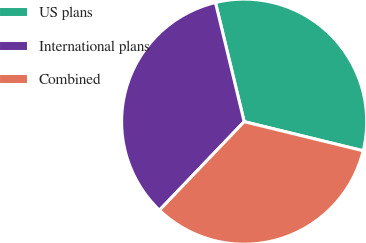Convert chart. <chart><loc_0><loc_0><loc_500><loc_500><pie_chart><fcel>US plans<fcel>International plans<fcel>Combined<nl><fcel>32.58%<fcel>34.09%<fcel>33.33%<nl></chart> 